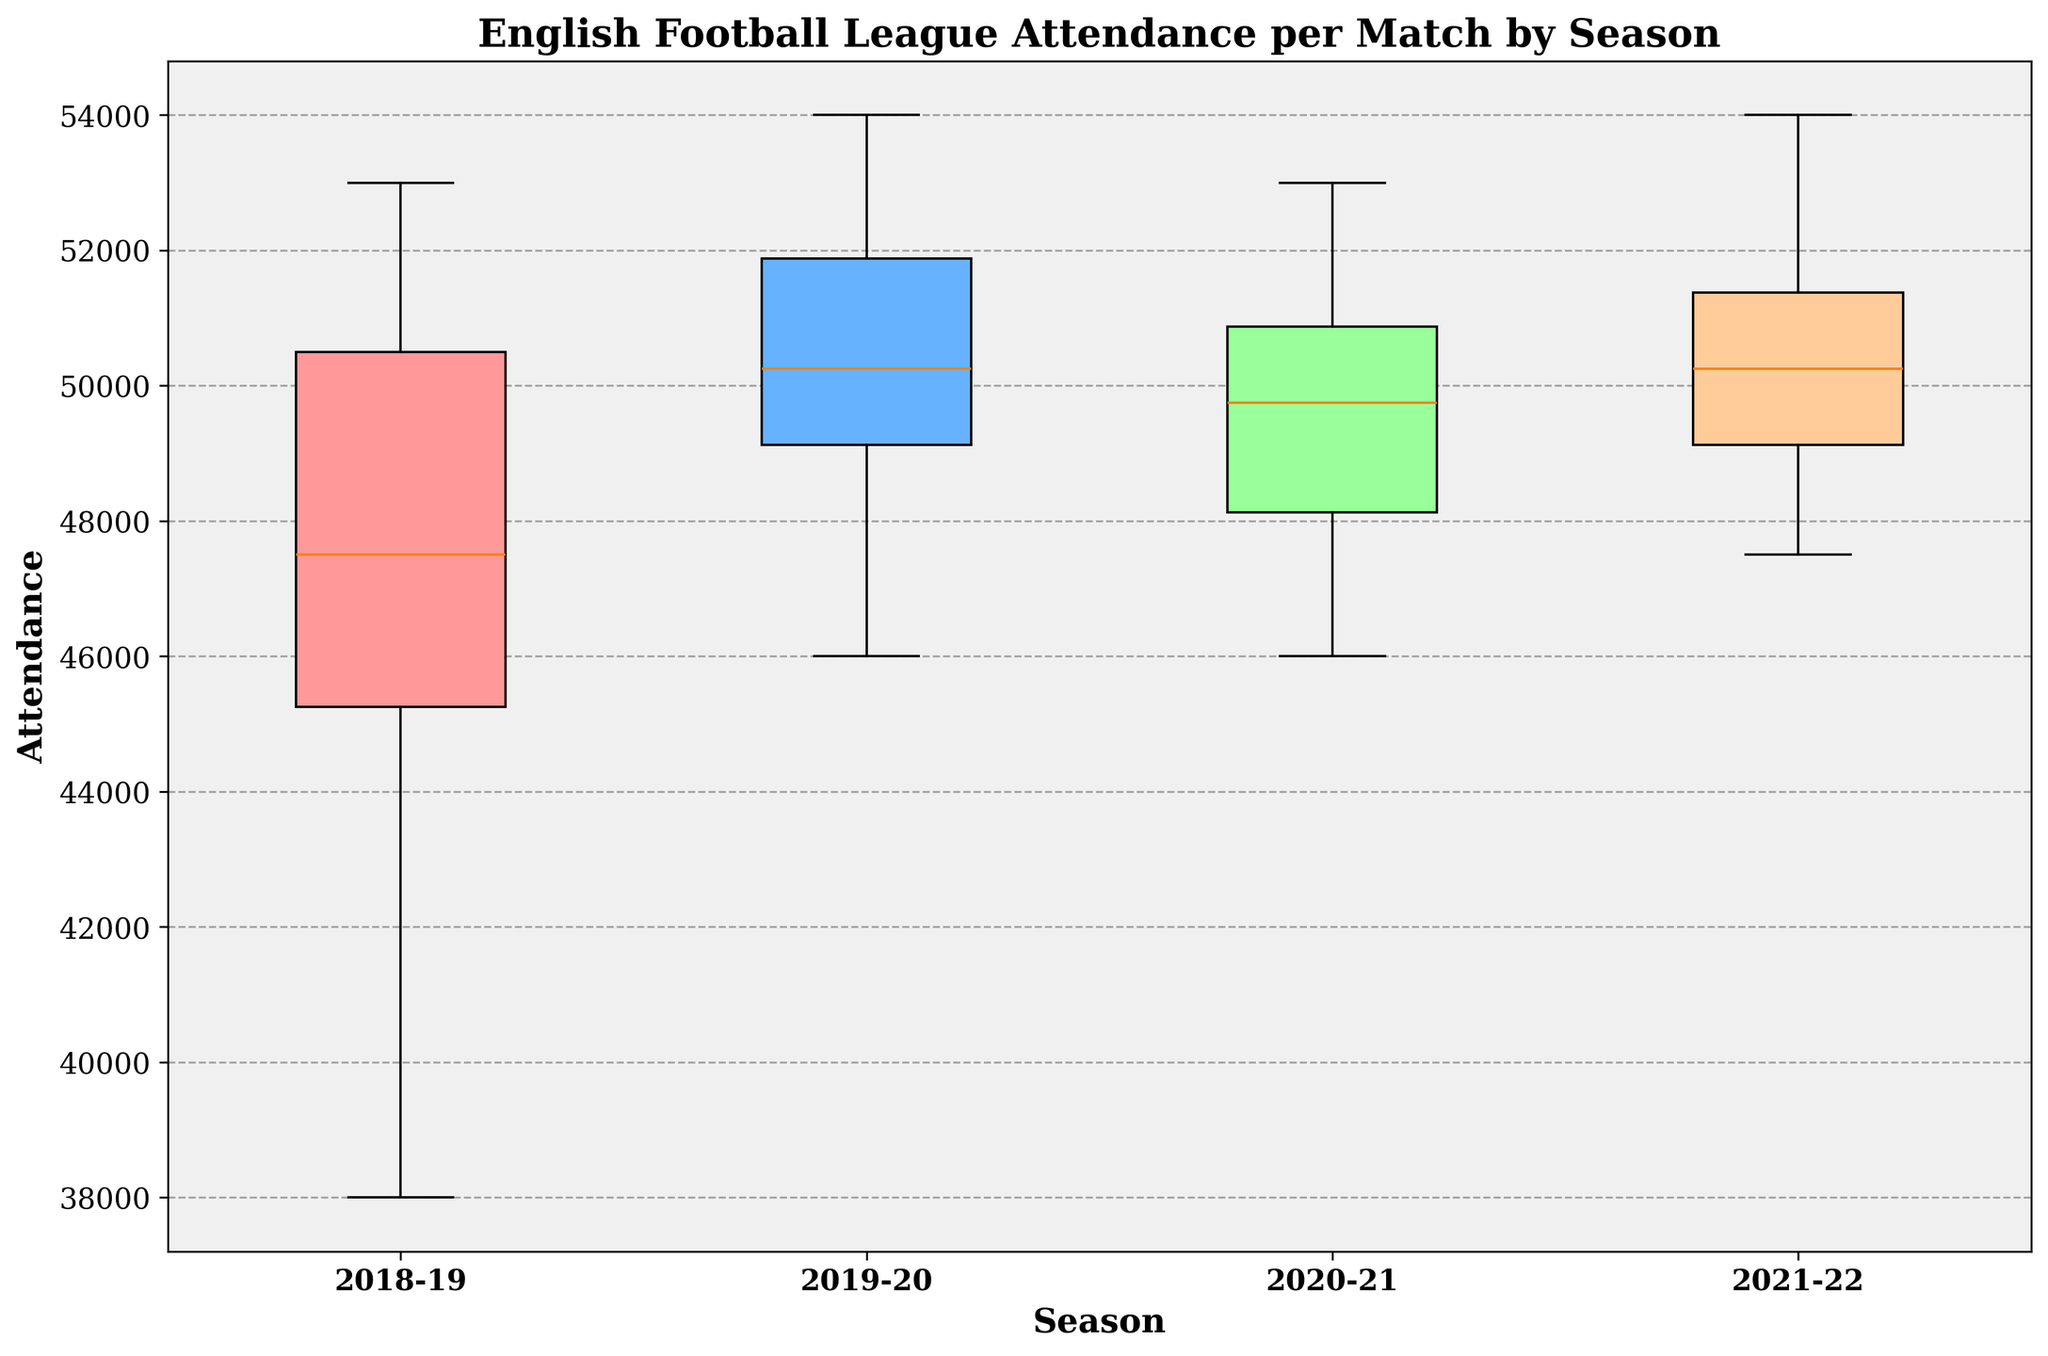How many seasons are represented in the plot? The box plot displays data for the different seasons in the dataset. By counting the unique labels on the x-axis, we can determine the number of seasons represented.
Answer: 4 Which season has the highest median attendance? To find the season with the highest median attendance, we look at the line inside each box that represents the median value. The season with the highest positioned line has the highest median attendance.
Answer: 2019-20 Which color is used to represent the 2018-19 season? Each season is represented by a differently colored box. By identifying the color of the first box from the left, we can determine the color representing the 2018-19 season.
Answer: Red What is the approximate interquartile range (IQR) for the 2021-22 season? The IQR is calculated by finding the difference between the upper quartile (the top of the box) and the lower quartile (the bottom of the box) for the corresponding season. Analyzing the height of the box, we can estimate the IQR.
Answer: 5000 Which season has the lowest variability in attendance? To determine the season with the lowest variability, we need to compare the heights of the boxes (representing the IQR). The shortest box will indicate the lowest variability.
Answer: 2019-20 What is the range of attendance values for the 2020-21 season? The range is the difference between the maximum and minimum values, indicated by the whiskers extending from the box. By examining the length of these whiskers for the 2020-21 season, we can estimate the range.
Answer: 7000 Compare the variability of attendance between the 2018-19 and 2021-22 seasons. To compare variability, we need to look at the IQR (height of the boxes) and the range (length of the whiskers). Analyzing these for both seasons helps us understand how spread out the values are.
Answer: 2018-19 has higher variability than 2021-22 Between which two seasons is the difference in median attendance the largest? By identifying the median lines inside the boxes of each season, we can calculate the differences in the median attendance between each pair of seasons and find the largest difference.
Answer: 2018-19 and 2019-20 What does the upper quartile value for the 2018-19 season represent? The upper quartile value is the top of the box for the 2018-19 season and represents the 75th percentile of the attendance values, which means 75% of the attendance values are below this point.
Answer: 51000 